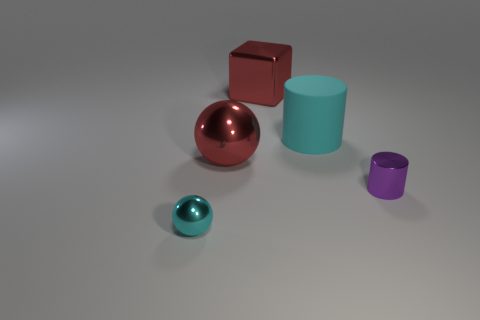What number of other objects are the same shape as the purple metallic object?
Give a very brief answer. 1. What is the shape of the matte thing?
Provide a short and direct response. Cylinder. Do the cyan ball and the purple cylinder have the same material?
Keep it short and to the point. Yes. Are there the same number of small cyan things that are to the right of the big cyan matte thing and cylinders on the left side of the cyan shiny sphere?
Offer a very short reply. Yes. There is a large metallic object that is on the right side of the red sphere left of the big matte object; is there a tiny sphere behind it?
Your answer should be very brief. No. Do the shiny block and the purple thing have the same size?
Make the answer very short. No. There is a tiny shiny object on the right side of the tiny object to the left of the cyan thing that is behind the cyan shiny sphere; what color is it?
Your answer should be very brief. Purple. What number of rubber things have the same color as the tiny metal sphere?
Your response must be concise. 1. What number of tiny objects are rubber things or yellow metallic objects?
Offer a very short reply. 0. Are there any small green matte objects of the same shape as the big cyan matte thing?
Make the answer very short. No. 